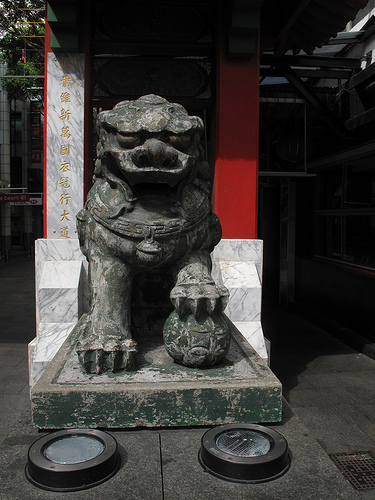<image>
Is there a gate on the statue? No. The gate is not positioned on the statue. They may be near each other, but the gate is not supported by or resting on top of the statue. 